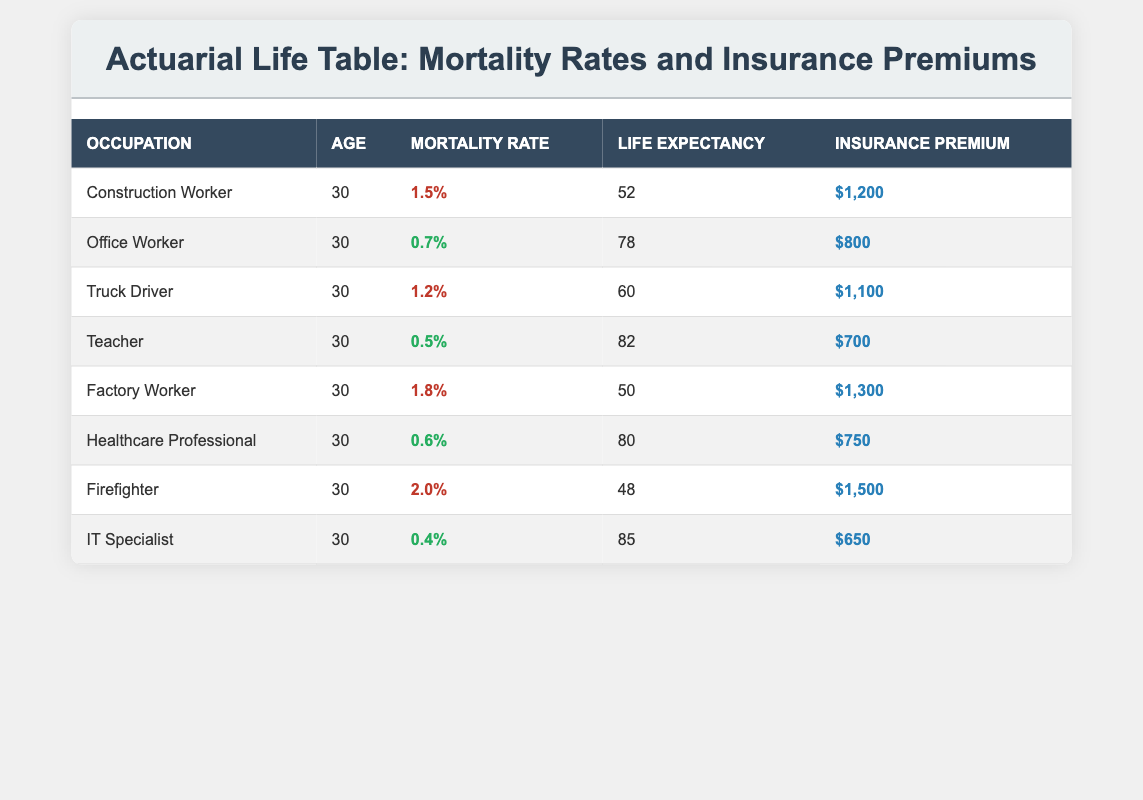What is the highest mortality rate among the listed professions? The table shows the mortality rates for different occupations. The highest rate listed is for the Firefighter at 0.020 (2.0%).
Answer: 2.0% Which profession has the lowest life expectancy? Looking at the Life Expectancy column, the Factory Worker has the lowest life expectancy, which is 50 years.
Answer: 50 years What is the average insurance premium for low-risk occupations? The low-risk professions are the Office Worker, Teacher, Healthcare Professional, and IT Specialist, with premiums of 800, 700, 750, and 650 respectively. Their sum is 800 + 700 + 750 + 650 = 2900. To find the average, divide by 4: 2900 / 4 = 725.
Answer: 725 Is the Mortality Rate for an IT Specialist lower than that of an Office Worker? The Mortality Rate for the IT Specialist is 0.004 (0.4%), while for the Office Worker, it is 0.007 (0.7%). Since 0.004 is less than 0.007, the statement is true.
Answer: Yes Which profession has the highest insurance premium? The table indicates that the Firefighter has the highest insurance premium at $1,500.
Answer: $1,500 What is the total insurance premium for high-risk occupations? The high-risk occupations are the Construction Worker, Truck Driver, Factory Worker, and Firefighter with premiums of 1200, 1100, 1300, and 1500 respectively. Their total is 1200 + 1100 + 1300 + 1500 = 5100.
Answer: $5,100 How much higher is the mortality rate of a Factory Worker compared to a Healthcare Professional? The mortality rate of a Factory Worker is 0.018 (1.8%), and for a Healthcare Professional, it is 0.006 (0.6%). The difference is 0.018 - 0.006 = 0.012 (1.2%).
Answer: 1.2% Do all professions listed have a life expectancy above 45 years? The table lists the life expectancy of all the occupations. Only the Firefighter has a life expectancy of 48, while the others are all above 45 years. Therefore, the answer is yes.
Answer: Yes What is the median life expectancy among the listed professions? The life expectancies are 52, 78, 60, 82, 50, 80, 48, and 85. To find the median, first sort the values: 48, 50, 52, 60, 78, 80, 82, 85. There are 8 values, so the median is the average of the 4th and 5th values: (60 + 78) / 2 = 69.
Answer: 69 